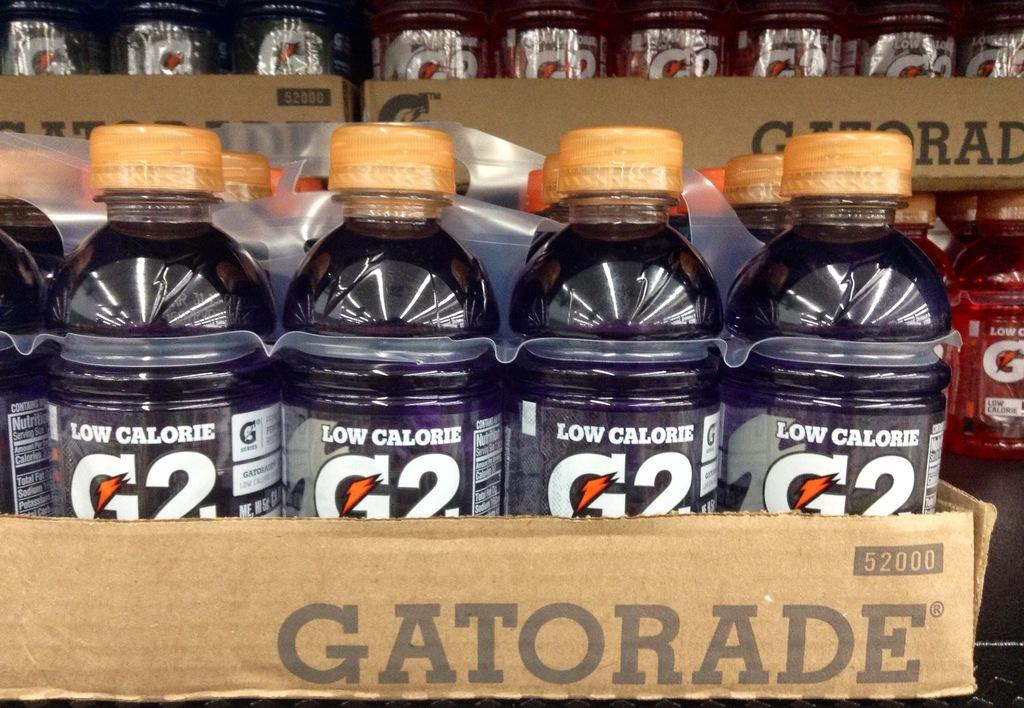Provide a one-sentence caption for the provided image. One of the versions of the low calorie beverage called G2 is purple in color. 